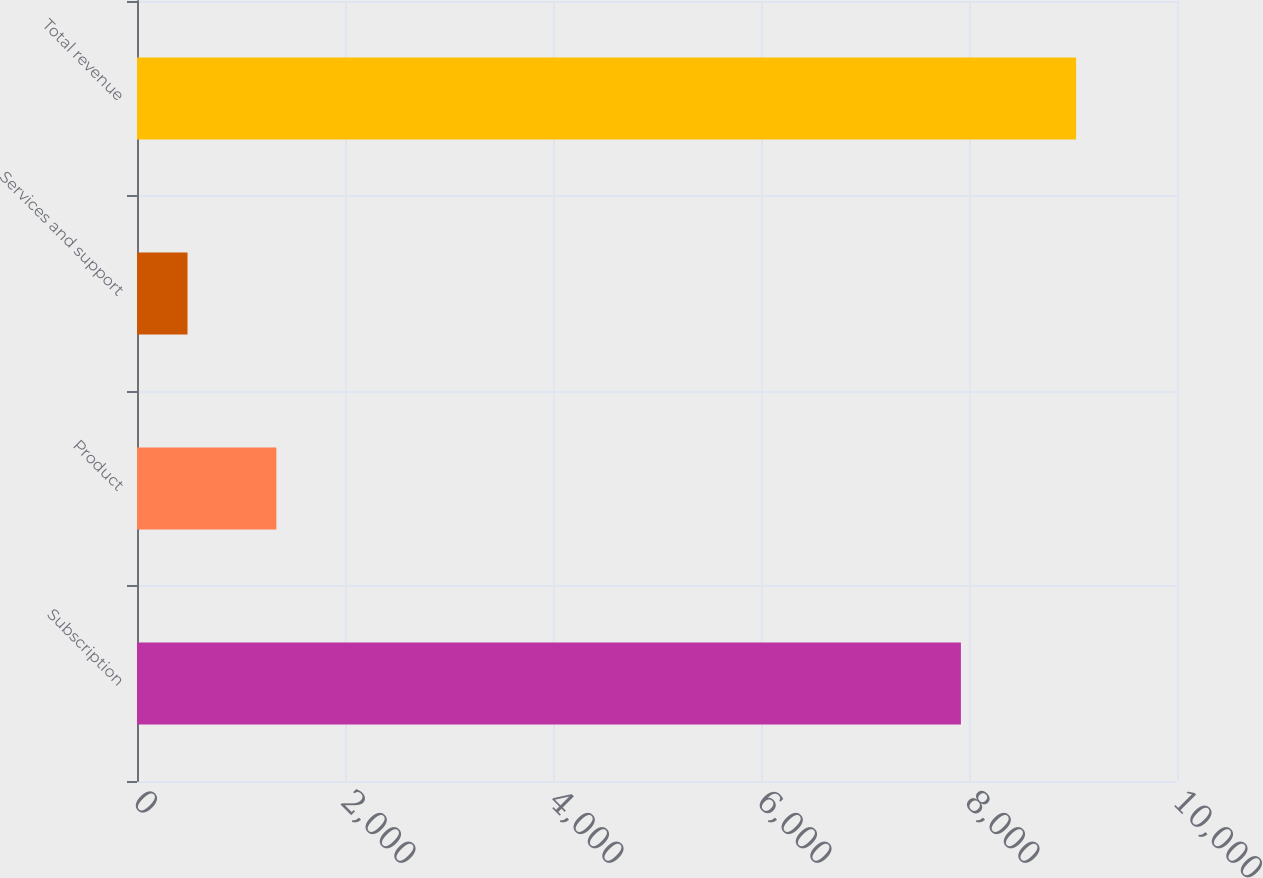<chart> <loc_0><loc_0><loc_500><loc_500><bar_chart><fcel>Subscription<fcel>Product<fcel>Services and support<fcel>Total revenue<nl><fcel>7922.2<fcel>1340.13<fcel>485.7<fcel>9030<nl></chart> 